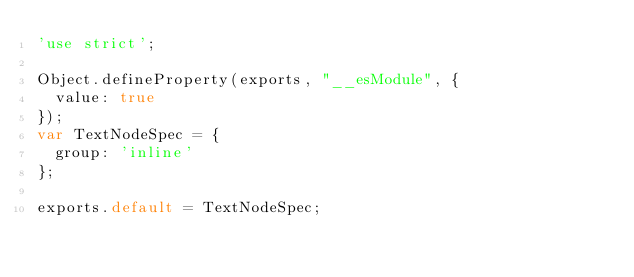Convert code to text. <code><loc_0><loc_0><loc_500><loc_500><_JavaScript_>'use strict';

Object.defineProperty(exports, "__esModule", {
  value: true
});
var TextNodeSpec = {
  group: 'inline'
};

exports.default = TextNodeSpec;</code> 